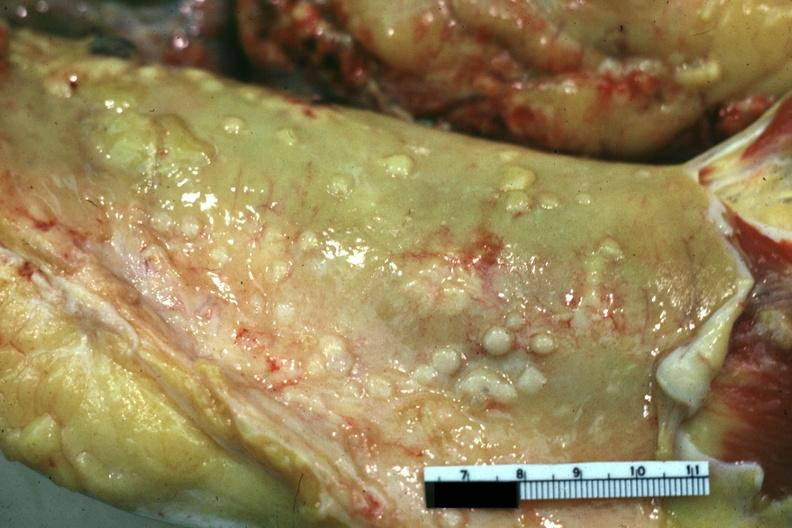s peritoneum present?
Answer the question using a single word or phrase. Yes 